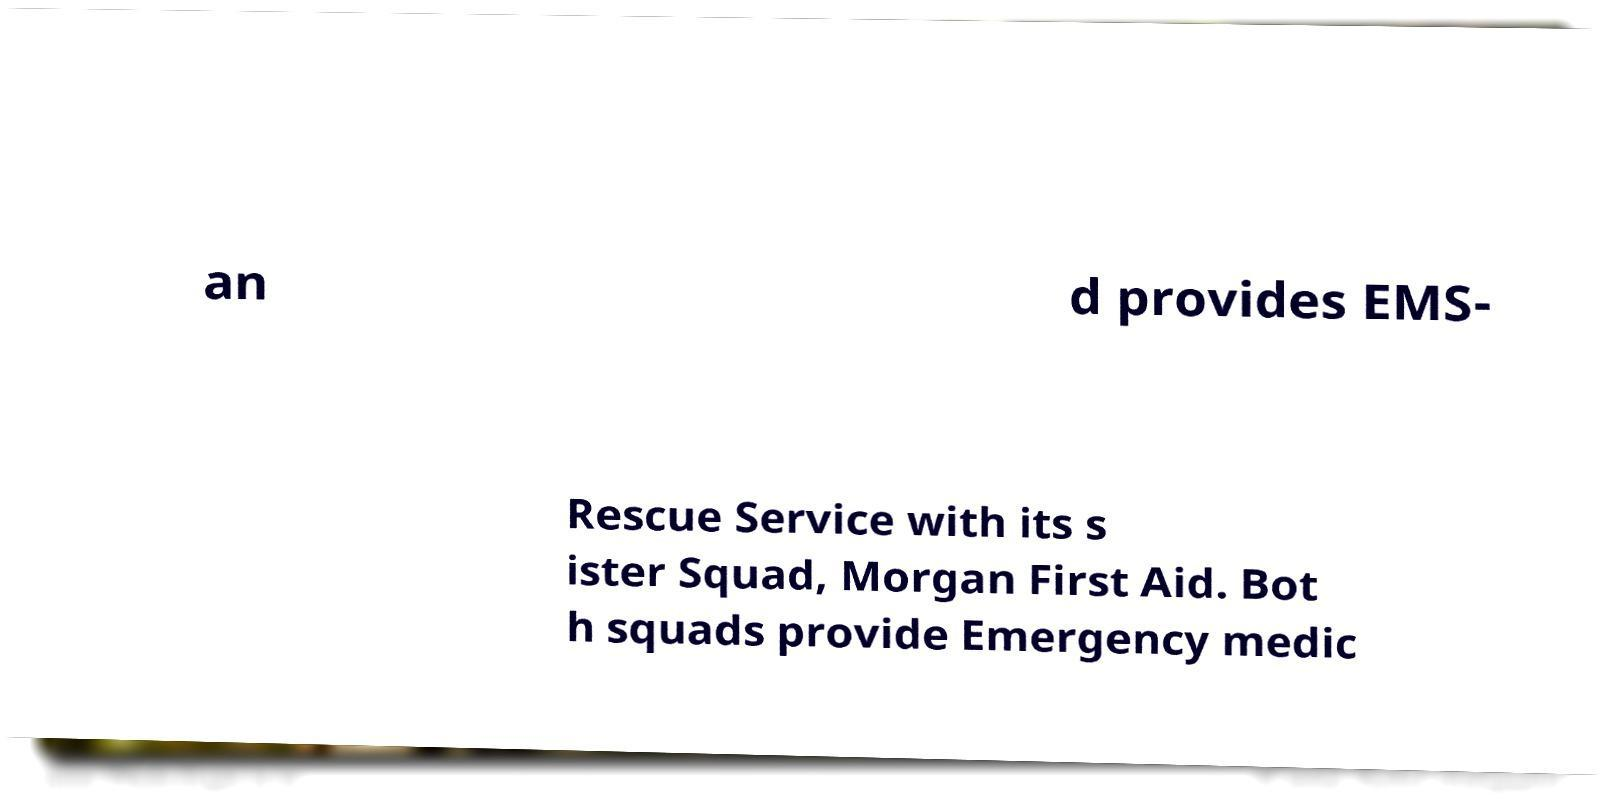Please identify and transcribe the text found in this image. an d provides EMS- Rescue Service with its s ister Squad, Morgan First Aid. Bot h squads provide Emergency medic 